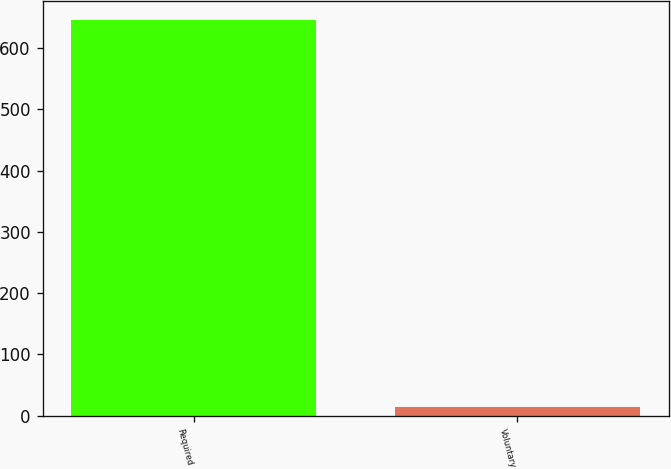Convert chart to OTSL. <chart><loc_0><loc_0><loc_500><loc_500><bar_chart><fcel>Required<fcel>Voluntary<nl><fcel>645<fcel>15<nl></chart> 